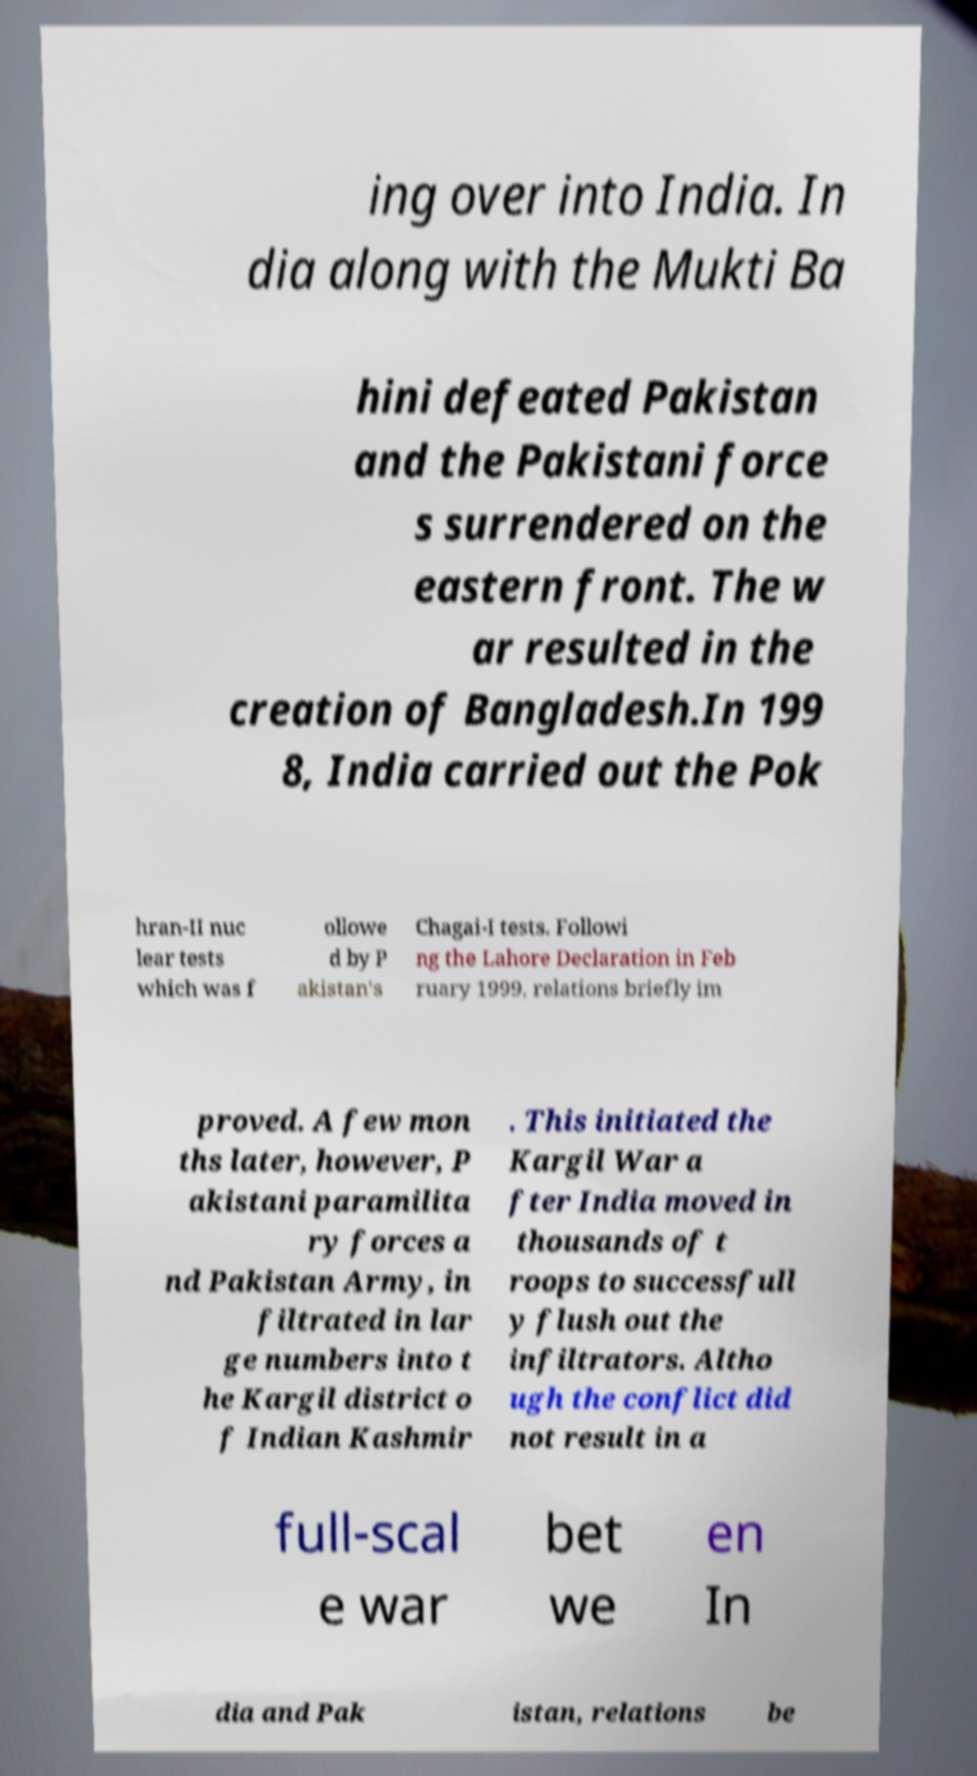Can you read and provide the text displayed in the image?This photo seems to have some interesting text. Can you extract and type it out for me? ing over into India. In dia along with the Mukti Ba hini defeated Pakistan and the Pakistani force s surrendered on the eastern front. The w ar resulted in the creation of Bangladesh.In 199 8, India carried out the Pok hran-II nuc lear tests which was f ollowe d by P akistan's Chagai-I tests. Followi ng the Lahore Declaration in Feb ruary 1999, relations briefly im proved. A few mon ths later, however, P akistani paramilita ry forces a nd Pakistan Army, in filtrated in lar ge numbers into t he Kargil district o f Indian Kashmir . This initiated the Kargil War a fter India moved in thousands of t roops to successfull y flush out the infiltrators. Altho ugh the conflict did not result in a full-scal e war bet we en In dia and Pak istan, relations be 